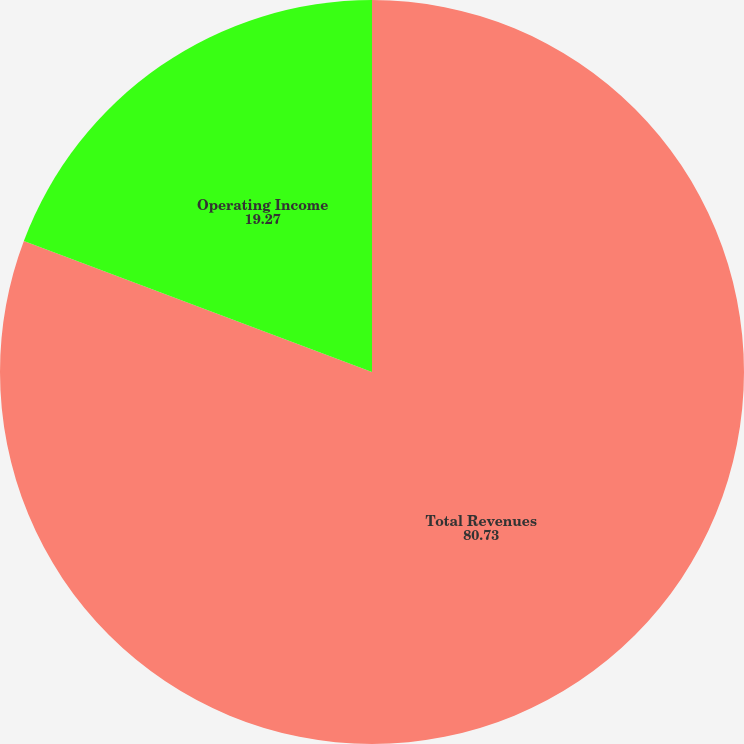Convert chart to OTSL. <chart><loc_0><loc_0><loc_500><loc_500><pie_chart><fcel>Total Revenues<fcel>Operating Income<nl><fcel>80.73%<fcel>19.27%<nl></chart> 